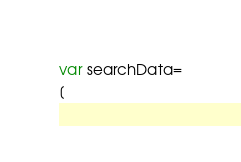Convert code to text. <code><loc_0><loc_0><loc_500><loc_500><_JavaScript_>var searchData=
[</code> 